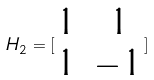Convert formula to latex. <formula><loc_0><loc_0><loc_500><loc_500>H _ { 2 } = [ \begin{matrix} 1 & 1 \\ 1 & - 1 \end{matrix} ]</formula> 